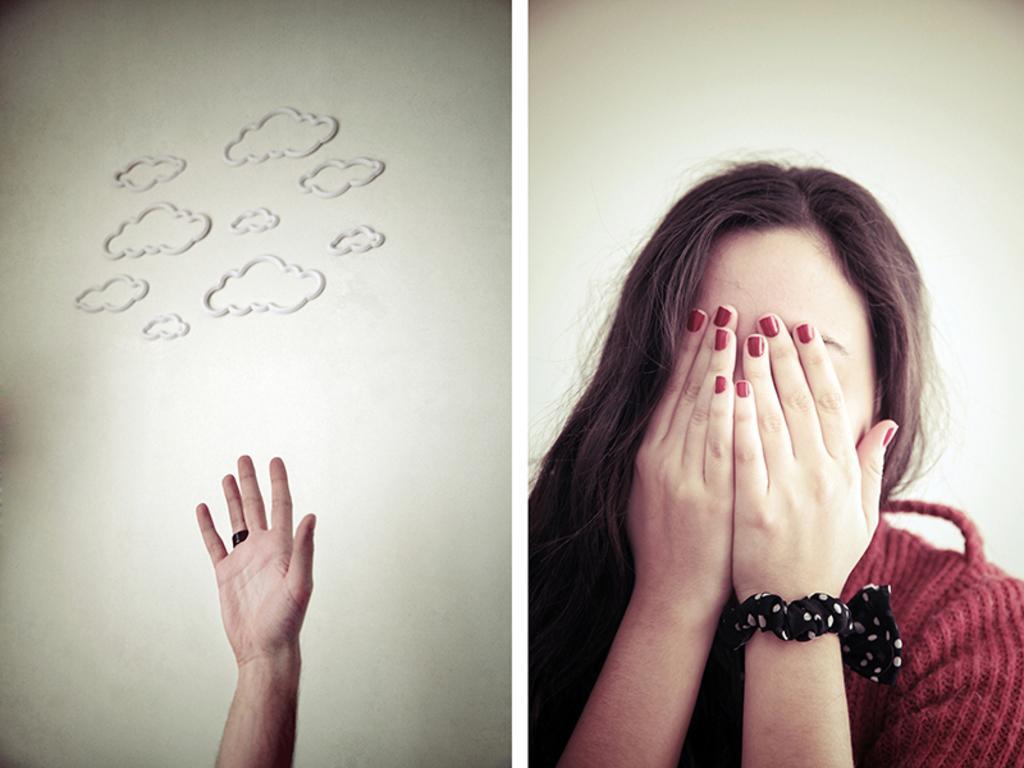In one or two sentences, can you explain what this image depicts? This is a collage picture. On the left side of the image there is a hand of a person and there are pictures of clouds on the wall. On the right side of the image there is a woman with red dress. At the back there is a wall. 